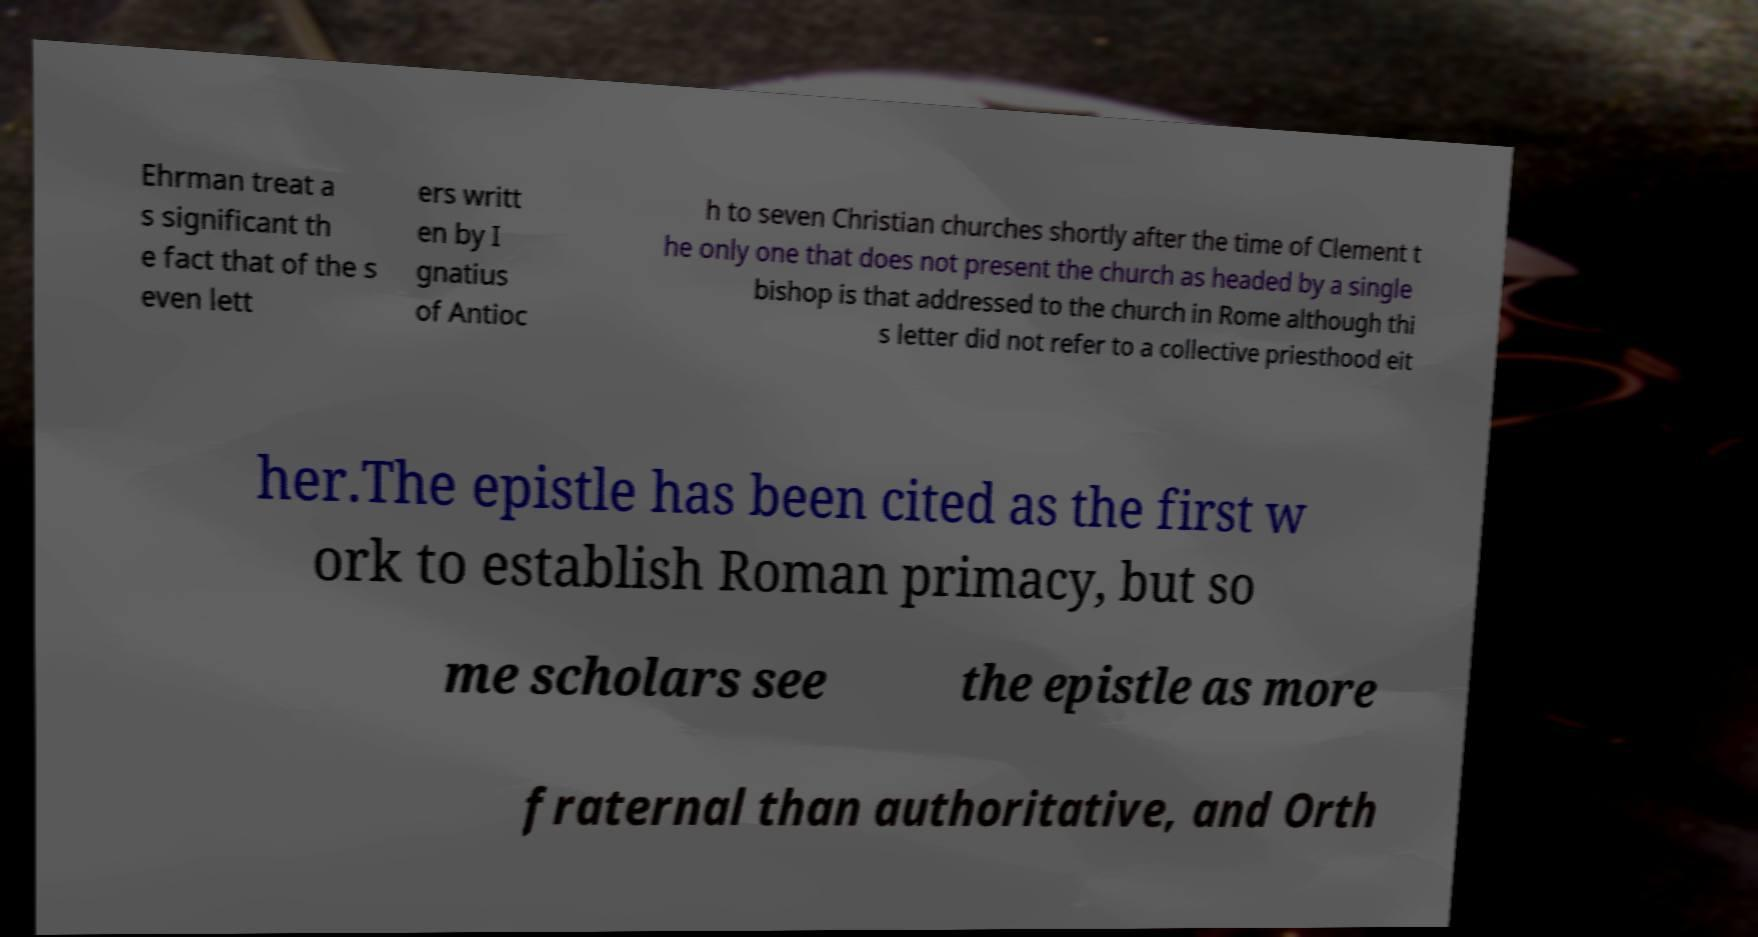Can you accurately transcribe the text from the provided image for me? Ehrman treat a s significant th e fact that of the s even lett ers writt en by I gnatius of Antioc h to seven Christian churches shortly after the time of Clement t he only one that does not present the church as headed by a single bishop is that addressed to the church in Rome although thi s letter did not refer to a collective priesthood eit her.The epistle has been cited as the first w ork to establish Roman primacy, but so me scholars see the epistle as more fraternal than authoritative, and Orth 